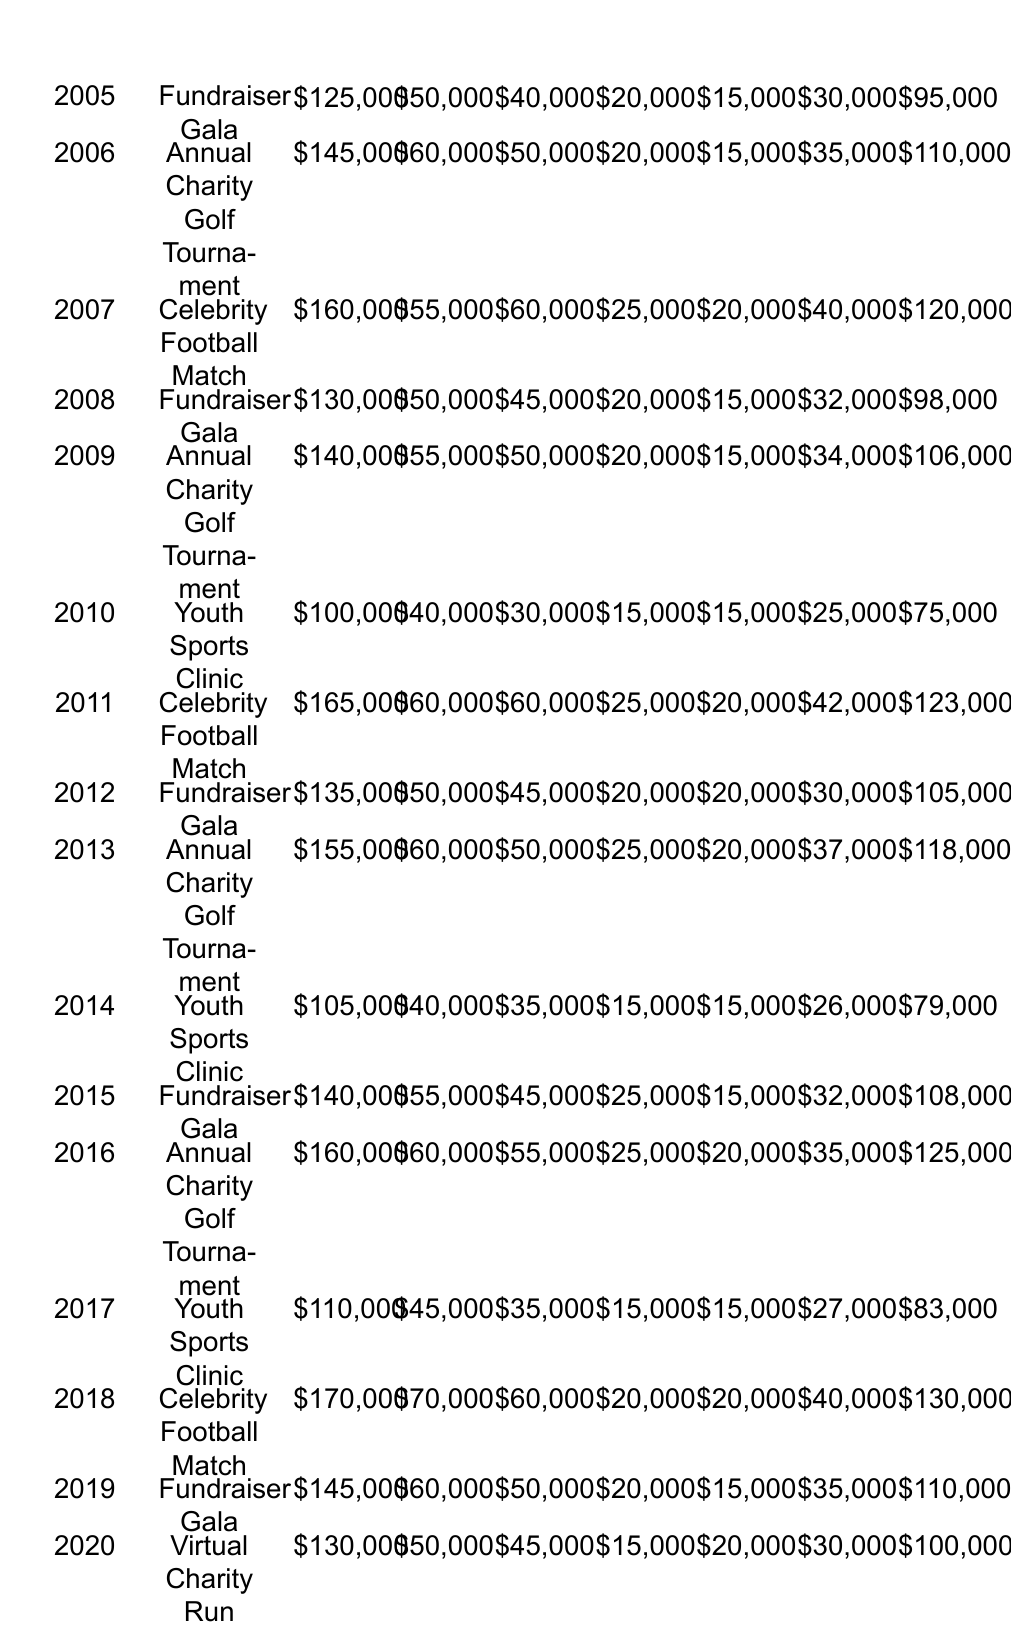What was the total net profit for the Celebrity Football Match in 2018? The table shows that the net profit for the Celebrity Football Match in 2018 was 130,000.
Answer: 130000 Which event had the highest total revenue and what was that revenue? The event with the highest total revenue was the Celebrity Football Match in 2018, with a revenue of 170,000.
Answer: 170000 What was the average ticket sales across all events from 2005 to 2020? To find the average ticket sales, sum the ticket sales: (50000 + 60000 + 55000 + 50000 + 55000 + 40000 + 60000 + 50000 + 60000 + 40000 + 55000 + 60000 + 45000 + 70000 + 60000 + 50000) = 850000. There are 16 events, so the average is 850000 / 16 = 53125.
Answer: 53125 Did the Annual Charity Golf Tournament have a net profit higher than 120000 in 2016? Looking at the table, the net profit for the Annual Charity Golf Tournament in 2016 was 125000, which is higher than 120000.
Answer: Yes How much more was raised from sponsorships in 2011 compared to 2010? The sponsorships raised in 2011 were 60000 and in 2010 were 30000. The difference is 60000 - 30000 = 30000.
Answer: 30000 What was the total revenue from all events in 2009 and 2010 combined? The total revenue for 2009 was 140000 and for 2010 it was 100000. Adding these together gives 140000 + 100000 = 240000.
Answer: 240000 Was the total revenue from the Fundraiser Gala events higher than 600000 across the years? The total revenue from the Fundraiser Gala events (2005, 2008, 2012, 2015, and 2019) is 125000 + 130000 + 135000 + 140000 + 145000 = 675000, which is indeed higher than 600000.
Answer: Yes Which event consistently had the lowest net profit from 2005 to 2020? When comparing the net profits from all events, the Youth Sports Clinic had the lowest profit of 75000 in 2010, making it the lowest net profit consistently from available years.
Answer: 75000 In which year did the Fundraiser Gala see a decrease in net profit compared to the previous year? The Fundraiser Gala in 2008 had a net profit of 98000, which is a decrease from 2007's profit of 120000. Thus, the year when the Gala saw a decrease is 2008.
Answer: 2008 